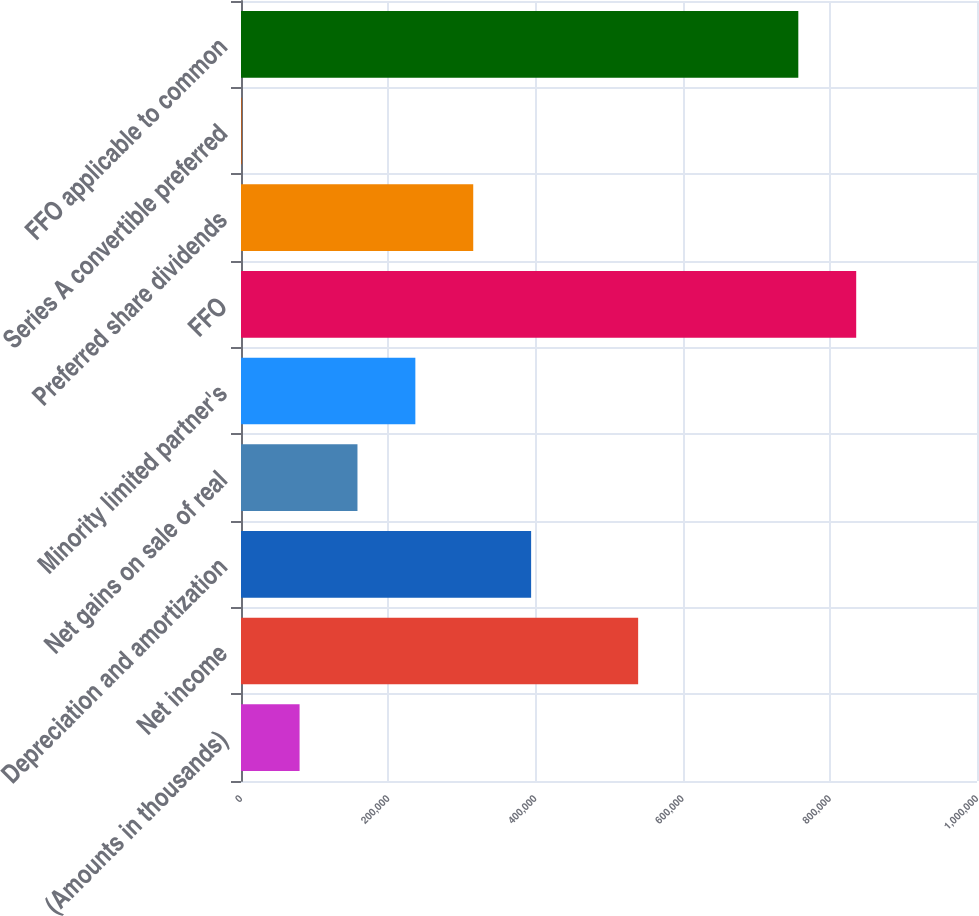<chart> <loc_0><loc_0><loc_500><loc_500><bar_chart><fcel>(Amounts in thousands)<fcel>Net income<fcel>Depreciation and amortization<fcel>Net gains on sale of real<fcel>Minority limited partner's<fcel>FFO<fcel>Preferred share dividends<fcel>Series A convertible preferred<fcel>FFO applicable to common<nl><fcel>79592.9<fcel>539604<fcel>394192<fcel>158243<fcel>236893<fcel>835869<fcel>315543<fcel>943<fcel>757219<nl></chart> 